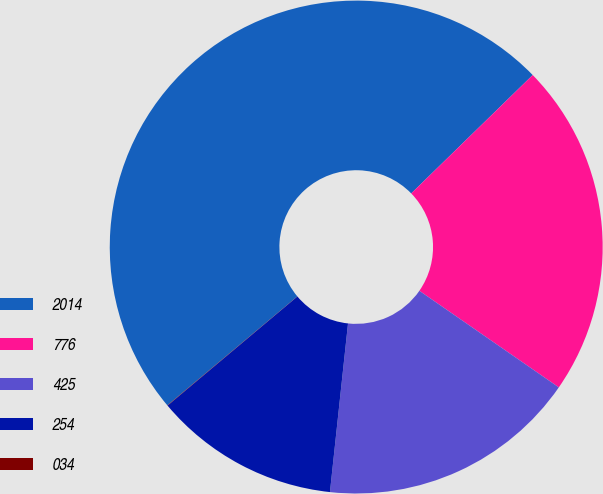Convert chart. <chart><loc_0><loc_0><loc_500><loc_500><pie_chart><fcel>2014<fcel>776<fcel>425<fcel>254<fcel>034<nl><fcel>48.81%<fcel>21.94%<fcel>17.06%<fcel>12.18%<fcel>0.02%<nl></chart> 